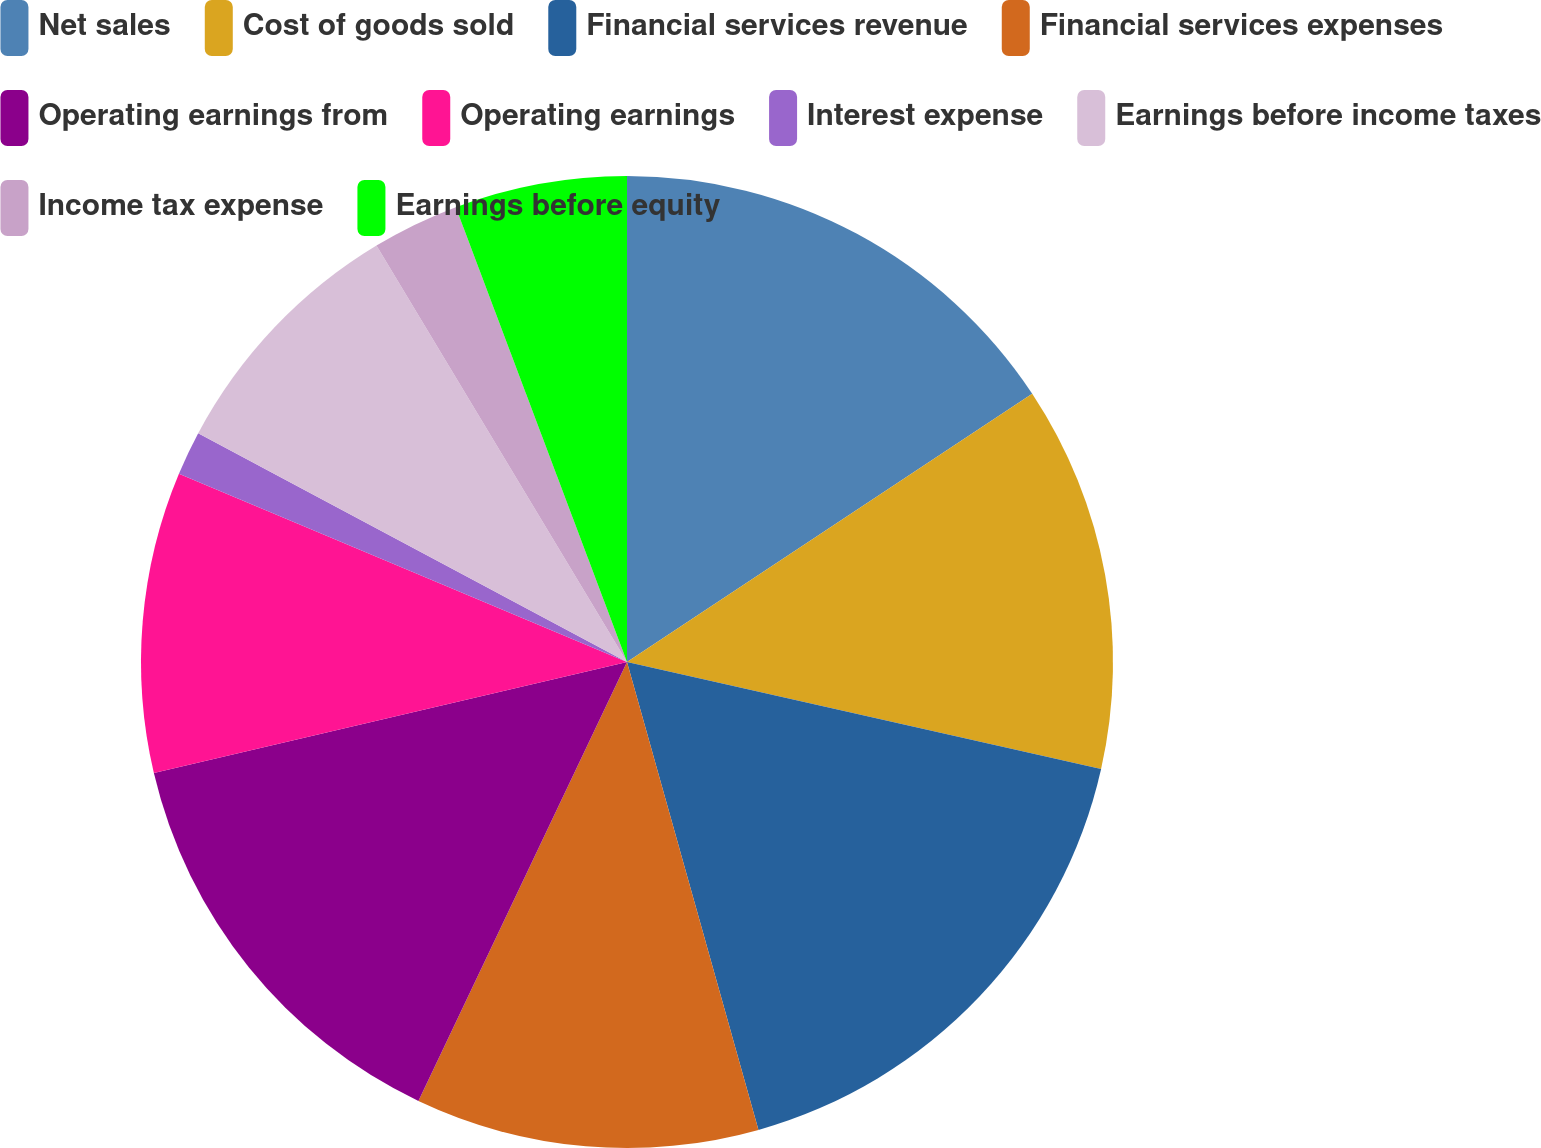Convert chart to OTSL. <chart><loc_0><loc_0><loc_500><loc_500><pie_chart><fcel>Net sales<fcel>Cost of goods sold<fcel>Financial services revenue<fcel>Financial services expenses<fcel>Operating earnings from<fcel>Operating earnings<fcel>Interest expense<fcel>Earnings before income taxes<fcel>Income tax expense<fcel>Earnings before equity<nl><fcel>15.69%<fcel>12.84%<fcel>17.11%<fcel>11.42%<fcel>14.27%<fcel>10.0%<fcel>1.47%<fcel>8.58%<fcel>2.89%<fcel>5.73%<nl></chart> 